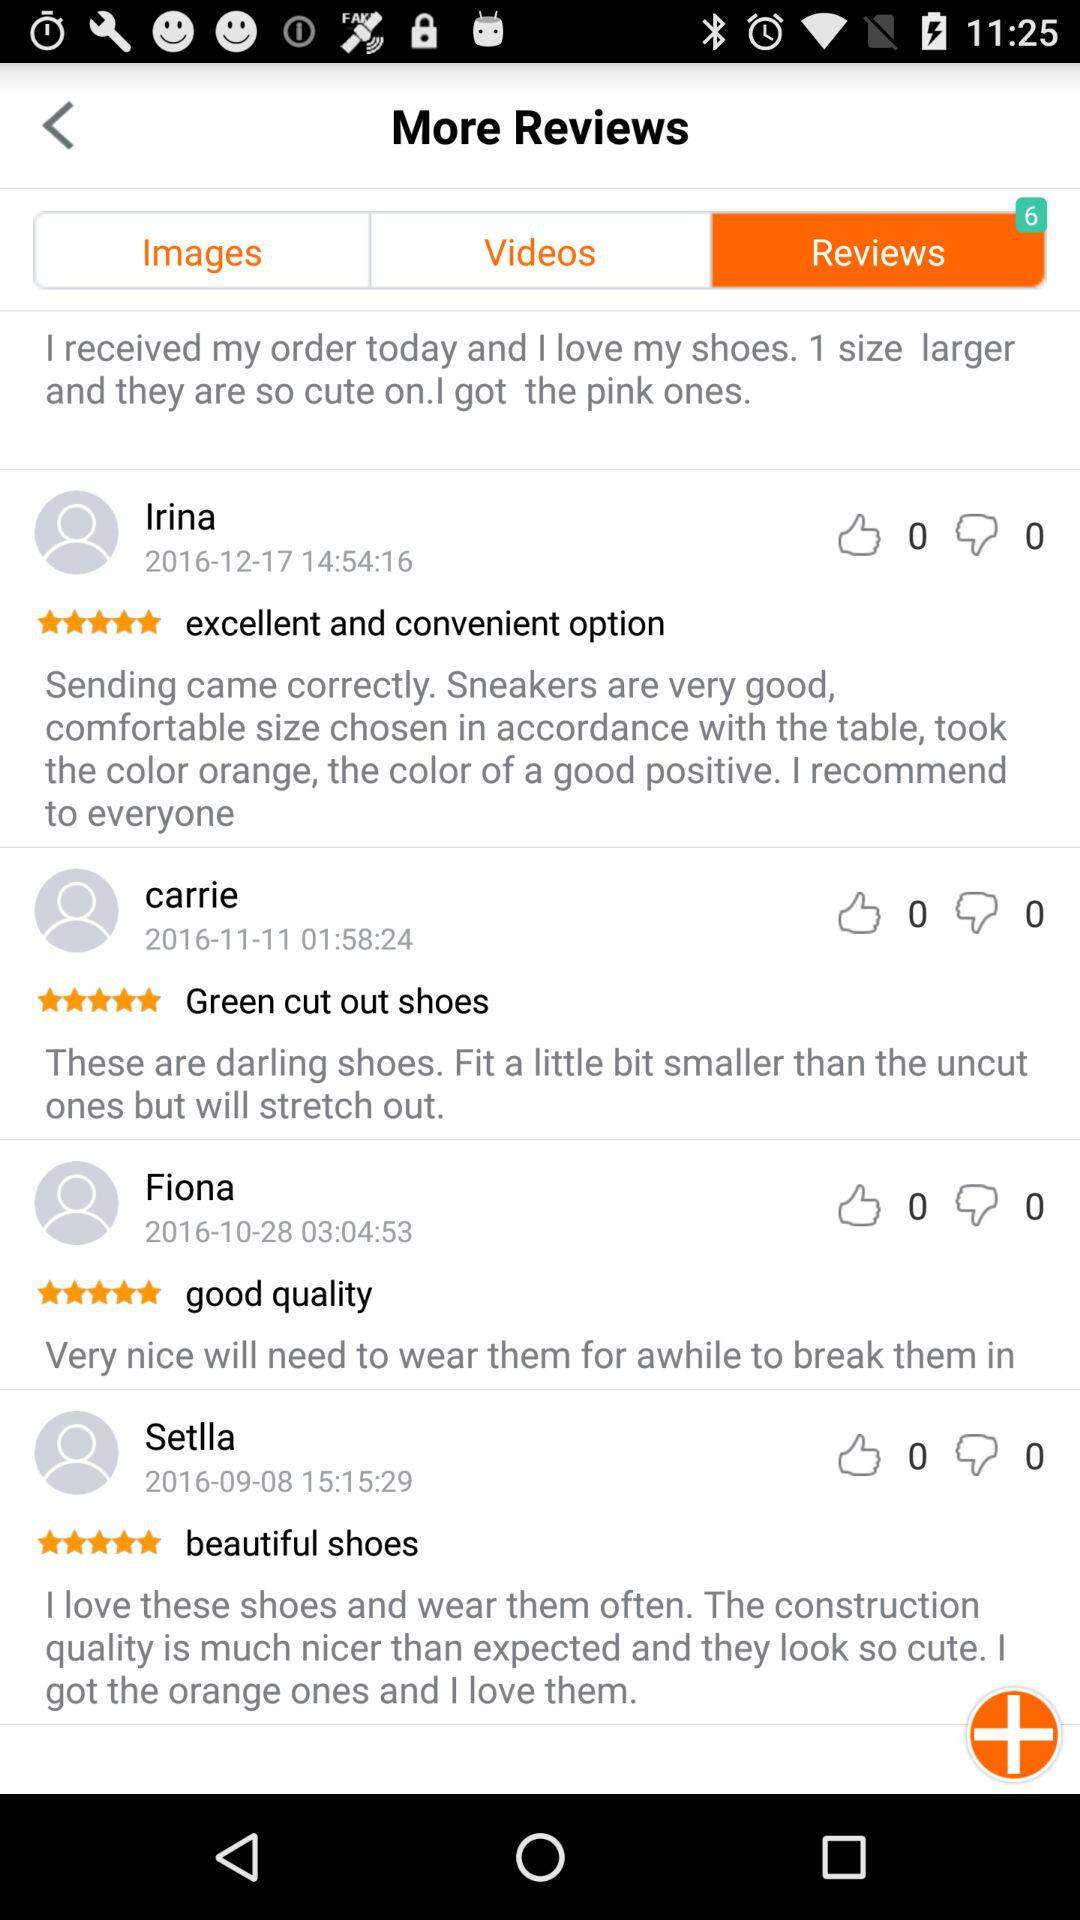On what date did Fiona post her review? Fiona posted her review on October 28, 2016. 